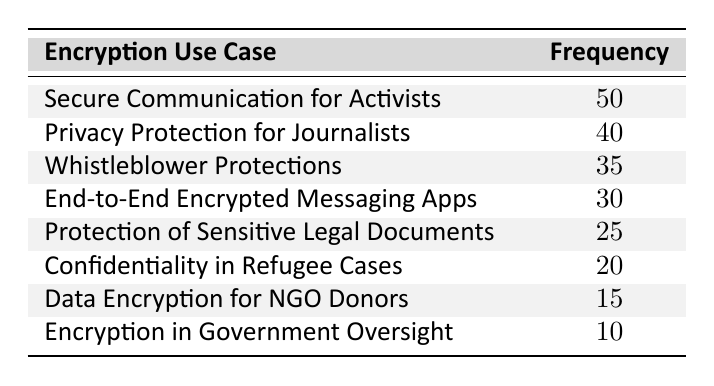What is the frequency of Secure Communication for Activists? The table lists Secure Communication for Activists with a frequency value of 50.
Answer: 50 Which use case has the lowest frequency? By examining the table, Encryption in Government Oversight shows the lowest frequency at 10.
Answer: 10 What is the total frequency of all use cases listed? To find the total frequency, sum all the values: 50 + 40 + 35 + 30 + 25 + 20 + 15 + 10 = 225.
Answer: 225 How many use cases have a frequency greater than 30? Looking through the table, the use cases with a frequency above 30 are Secure Communication for Activists (50), Privacy Protection for Journalists (40), and Whistleblower Protections (35). That totals 3 use cases.
Answer: 3 Is there a use case with a frequency of 15? Reviewing the table, Data Encryption for NGO Donors has a frequency of 15, confirming the presence of this value.
Answer: Yes What is the difference in frequency between Whistleblower Protections and Data Encryption for NGO Donors? The frequency of Whistleblower Protections is 35 and for Data Encryption for NGO Donors it is 15. The difference is 35 - 15 = 20.
Answer: 20 What is the average frequency of the use cases concerning refugee cases and whistleblower protections? The frequencies are 20 for Confidentiality in Refugee Cases and 35 for Whistleblower Protections. The average is calculated as (20 + 35) / 2 = 27.5.
Answer: 27.5 Are there more use cases focused on journalist protection or refugee cases? The table shows Privacy Protection for Journalists (40) versus Confidentiality in Refugee Cases (20). Since 40 is greater than 20, there are more focused on journalism.
Answer: Yes Which use case has a frequency that is 5 more than End-to-End Encrypted Messaging Apps? The frequency for End-to-End Encrypted Messaging Apps is 30. Adding 5 gives 35, which corresponds to Whistleblower Protections. The answer confirms this finding.
Answer: Whistleblower Protections 